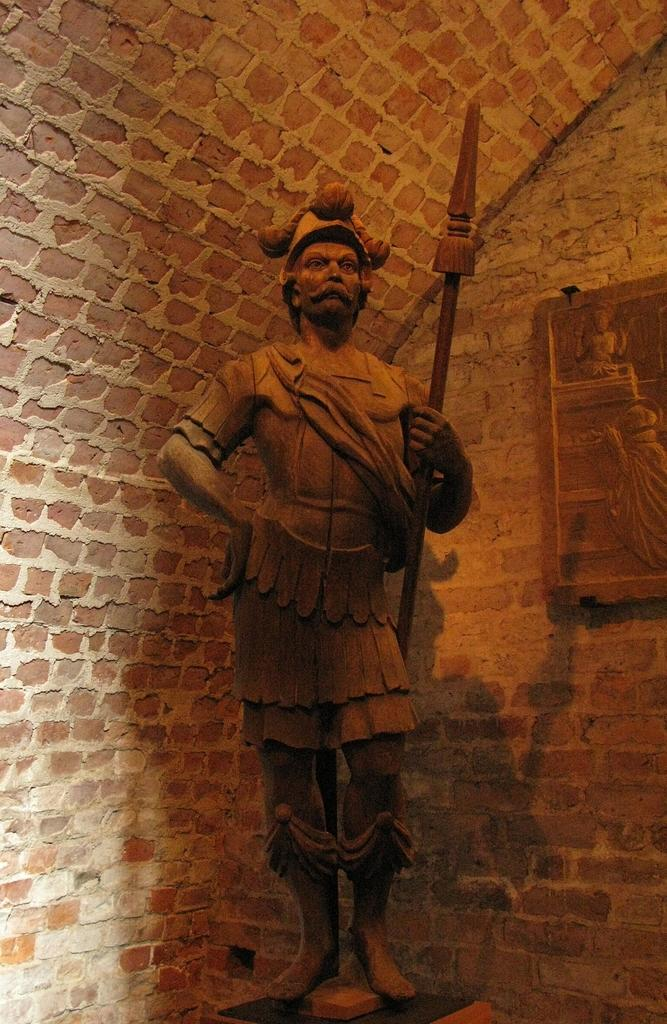What is the main subject of the image? There is a statue of a man in the image. What is the man holding in the image? The man is holding a spear. What can be seen in the background of the image? There is a wall in the background of the image. What is the purpose of the frame in the image? The purpose of the frame in the image is not specified, but it could be used for displaying or protecting the statue. How many cent ducks are swimming in the water near the statue? There are no cent ducks present in the image, and there is no water visible in the image. 